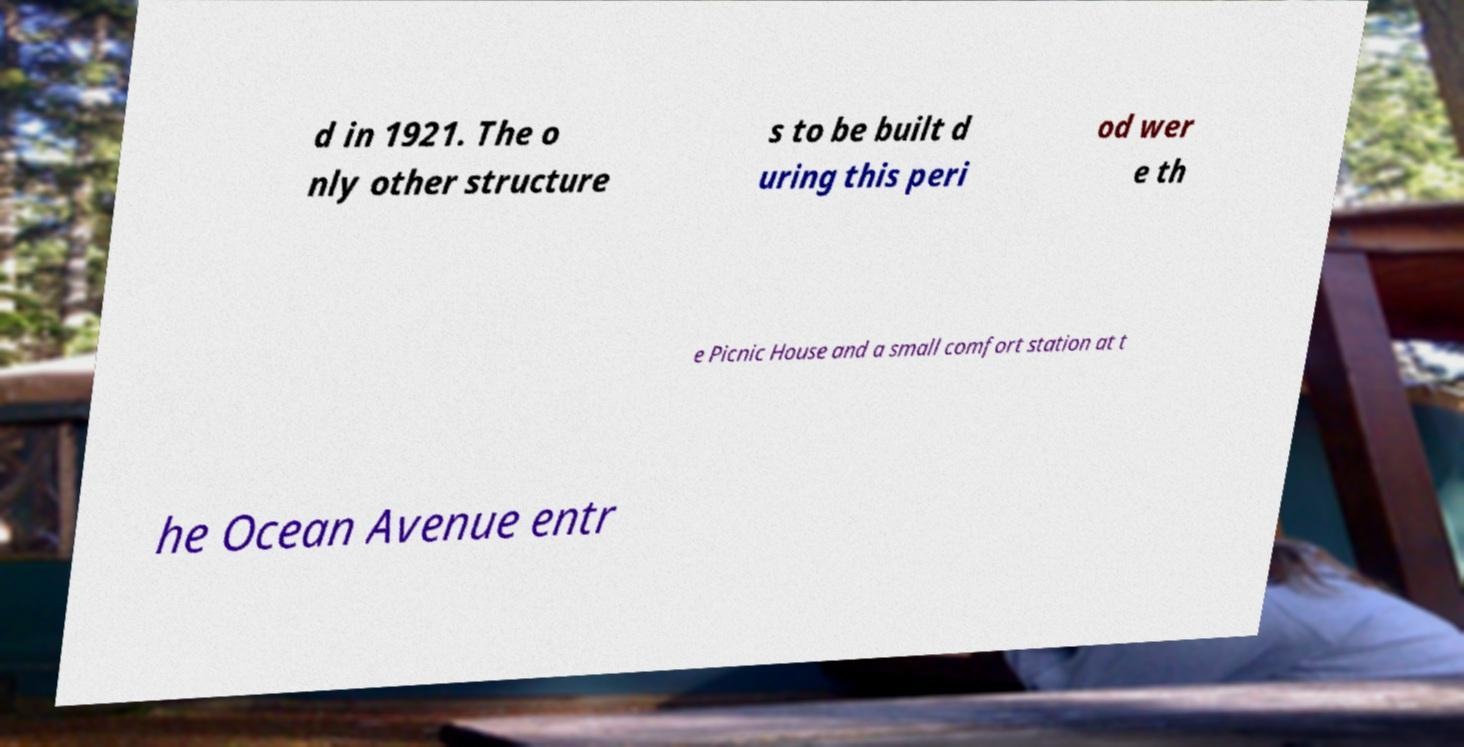For documentation purposes, I need the text within this image transcribed. Could you provide that? d in 1921. The o nly other structure s to be built d uring this peri od wer e th e Picnic House and a small comfort station at t he Ocean Avenue entr 